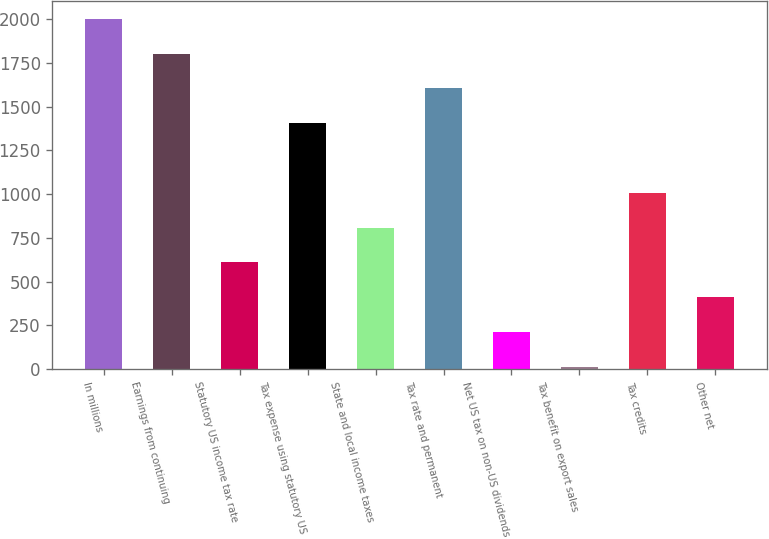<chart> <loc_0><loc_0><loc_500><loc_500><bar_chart><fcel>In millions<fcel>Earnings from continuing<fcel>Statutory US income tax rate<fcel>Tax expense using statutory US<fcel>State and local income taxes<fcel>Tax rate and permanent<fcel>Net US tax on non-US dividends<fcel>Tax benefit on export sales<fcel>Tax credits<fcel>Other net<nl><fcel>2003<fcel>1803.9<fcel>609.3<fcel>1405.7<fcel>808.4<fcel>1604.8<fcel>211.1<fcel>12<fcel>1007.5<fcel>410.2<nl></chart> 